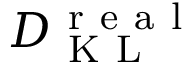<formula> <loc_0><loc_0><loc_500><loc_500>D _ { K L } ^ { r e a l }</formula> 